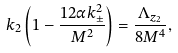<formula> <loc_0><loc_0><loc_500><loc_500>k _ { 2 } \left ( 1 - \frac { 1 2 \alpha k _ { \pm } ^ { 2 } } { M ^ { 2 } } \right ) = \frac { \Lambda _ { z _ { 2 } } } { 8 M ^ { 4 } } ,</formula> 